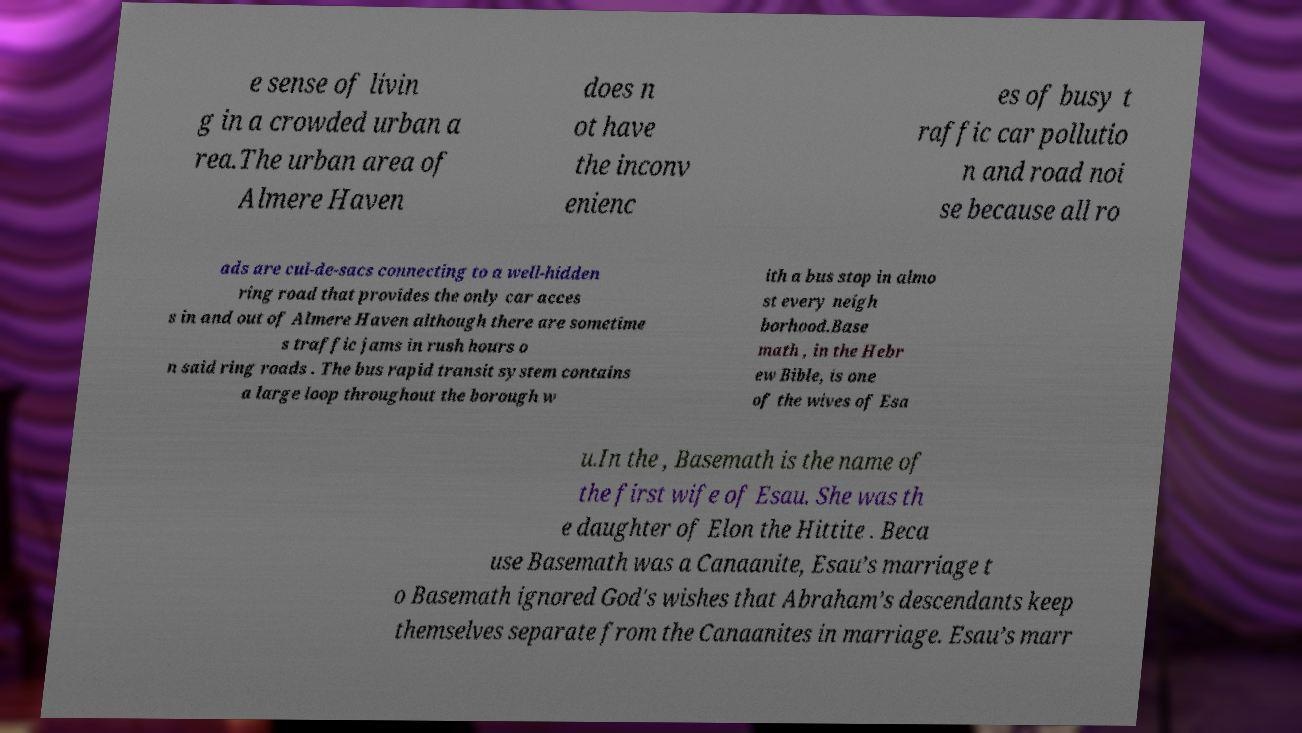Could you extract and type out the text from this image? e sense of livin g in a crowded urban a rea.The urban area of Almere Haven does n ot have the inconv enienc es of busy t raffic car pollutio n and road noi se because all ro ads are cul-de-sacs connecting to a well-hidden ring road that provides the only car acces s in and out of Almere Haven although there are sometime s traffic jams in rush hours o n said ring roads . The bus rapid transit system contains a large loop throughout the borough w ith a bus stop in almo st every neigh borhood.Base math , in the Hebr ew Bible, is one of the wives of Esa u.In the , Basemath is the name of the first wife of Esau. She was th e daughter of Elon the Hittite . Beca use Basemath was a Canaanite, Esau’s marriage t o Basemath ignored God's wishes that Abraham’s descendants keep themselves separate from the Canaanites in marriage. Esau’s marr 